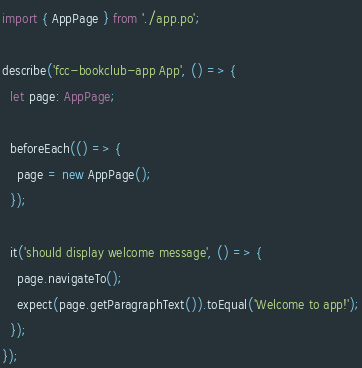Convert code to text. <code><loc_0><loc_0><loc_500><loc_500><_TypeScript_>import { AppPage } from './app.po';

describe('fcc-bookclub-app App', () => {
  let page: AppPage;

  beforeEach(() => {
    page = new AppPage();
  });

  it('should display welcome message', () => {
    page.navigateTo();
    expect(page.getParagraphText()).toEqual('Welcome to app!');
  });
});
</code> 